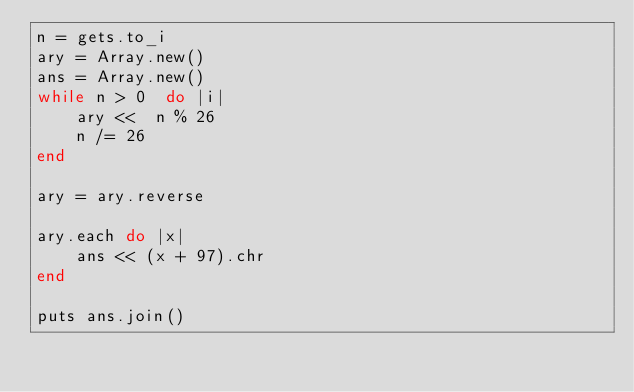Convert code to text. <code><loc_0><loc_0><loc_500><loc_500><_Ruby_>n = gets.to_i
ary = Array.new()
ans = Array.new()
while n > 0  do |i|
    ary <<  n % 26
    n /= 26
end

ary = ary.reverse

ary.each do |x|
    ans << (x + 97).chr
end

puts ans.join()
</code> 